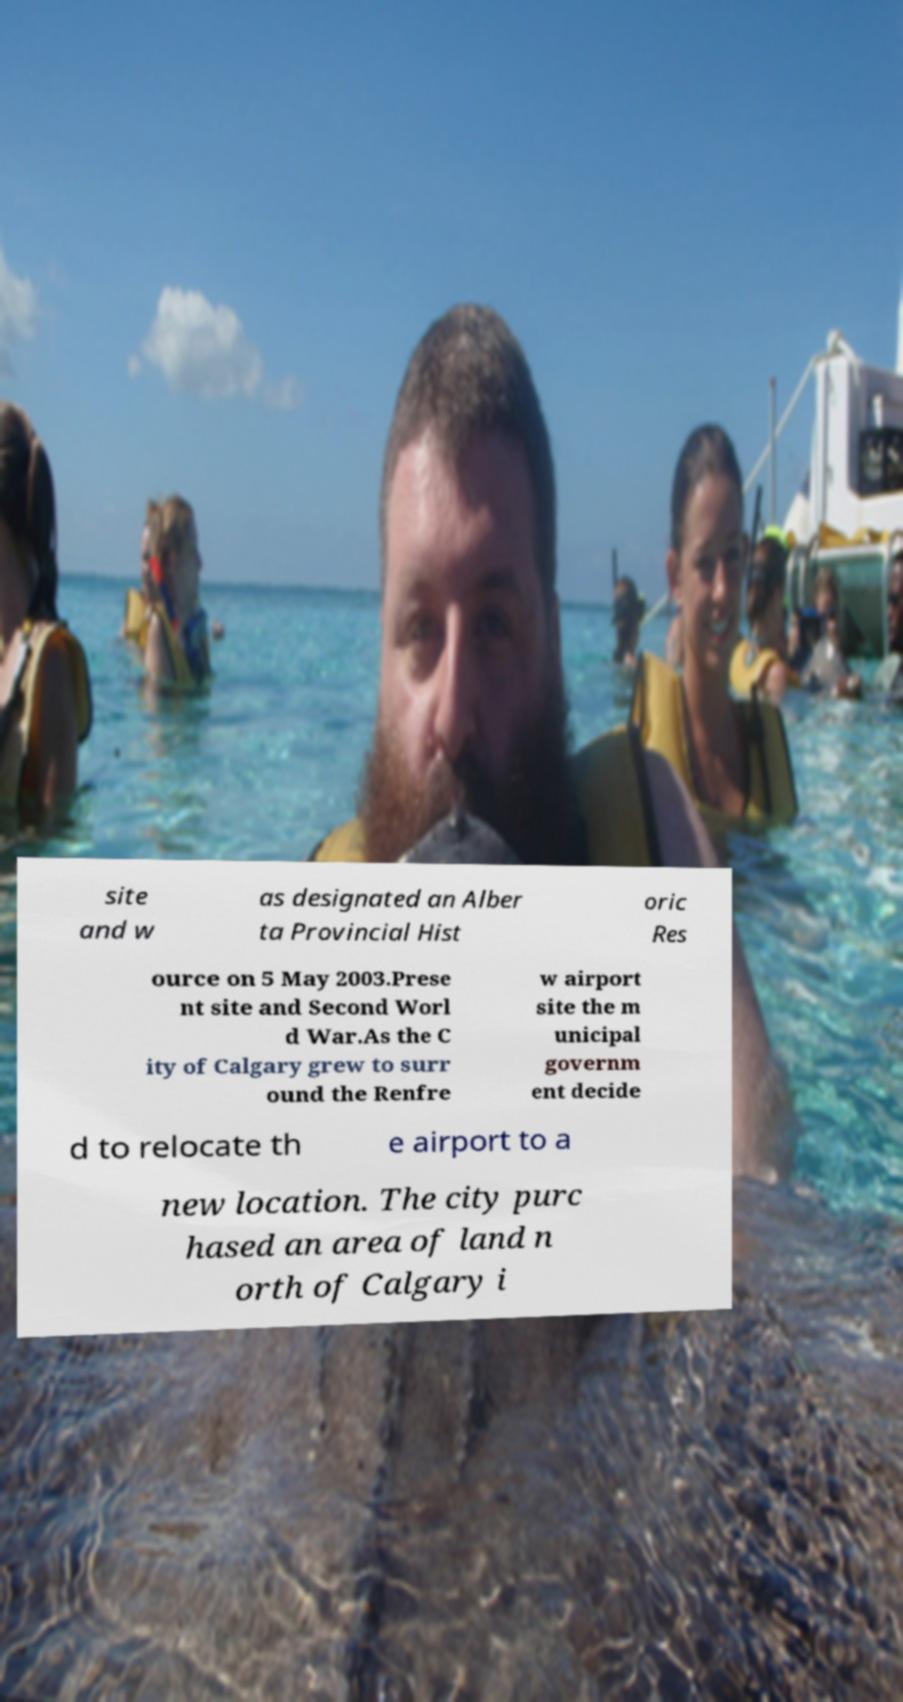Please identify and transcribe the text found in this image. site and w as designated an Alber ta Provincial Hist oric Res ource on 5 May 2003.Prese nt site and Second Worl d War.As the C ity of Calgary grew to surr ound the Renfre w airport site the m unicipal governm ent decide d to relocate th e airport to a new location. The city purc hased an area of land n orth of Calgary i 